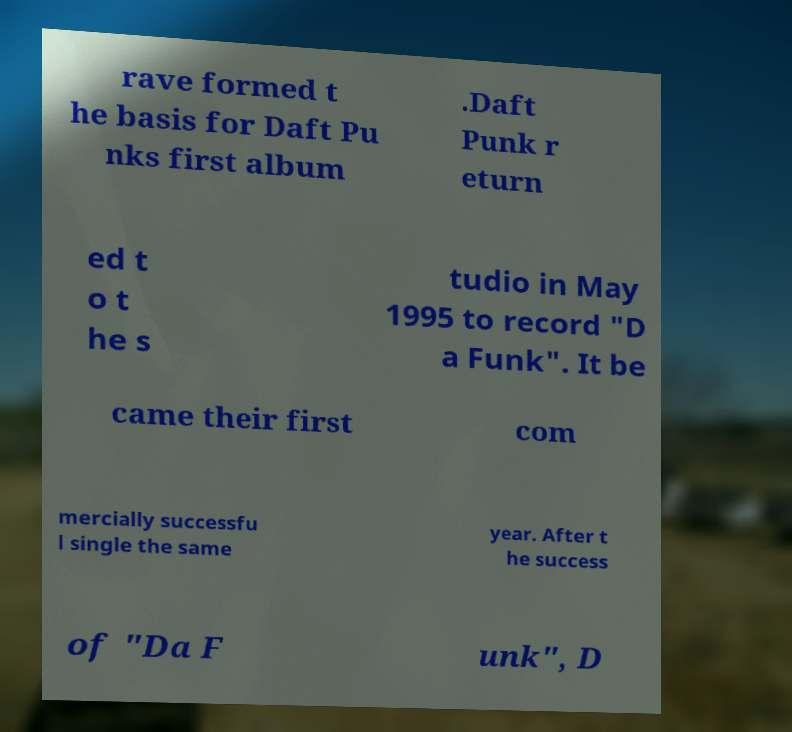Can you read and provide the text displayed in the image?This photo seems to have some interesting text. Can you extract and type it out for me? rave formed t he basis for Daft Pu nks first album .Daft Punk r eturn ed t o t he s tudio in May 1995 to record "D a Funk". It be came their first com mercially successfu l single the same year. After t he success of "Da F unk", D 